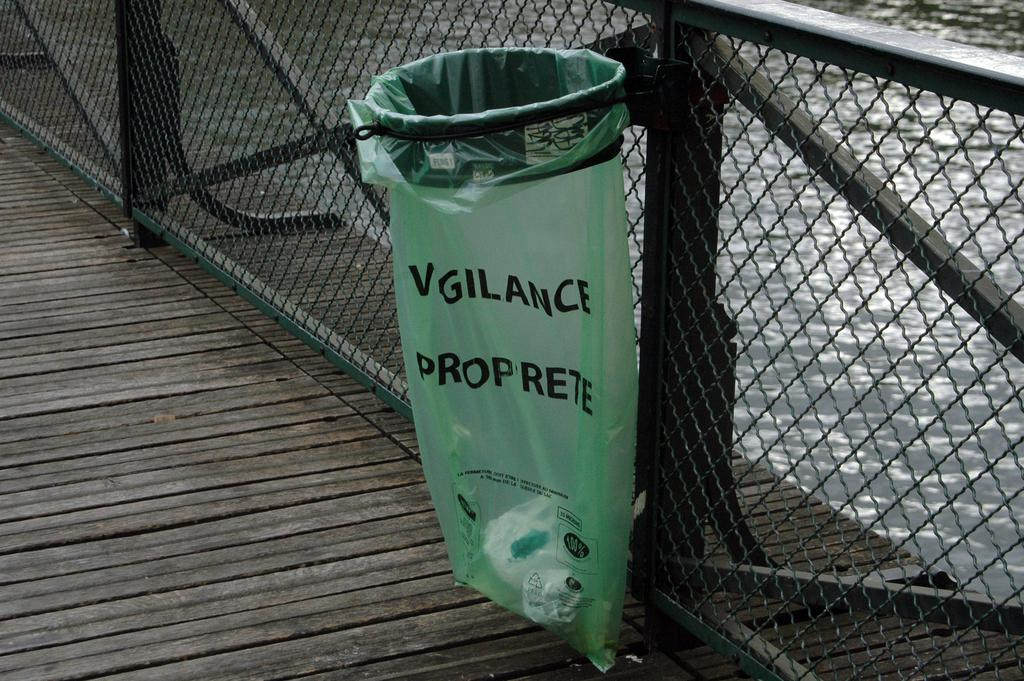<image>
Relay a brief, clear account of the picture shown. a green trash can bag that says Vigilance proprete. 